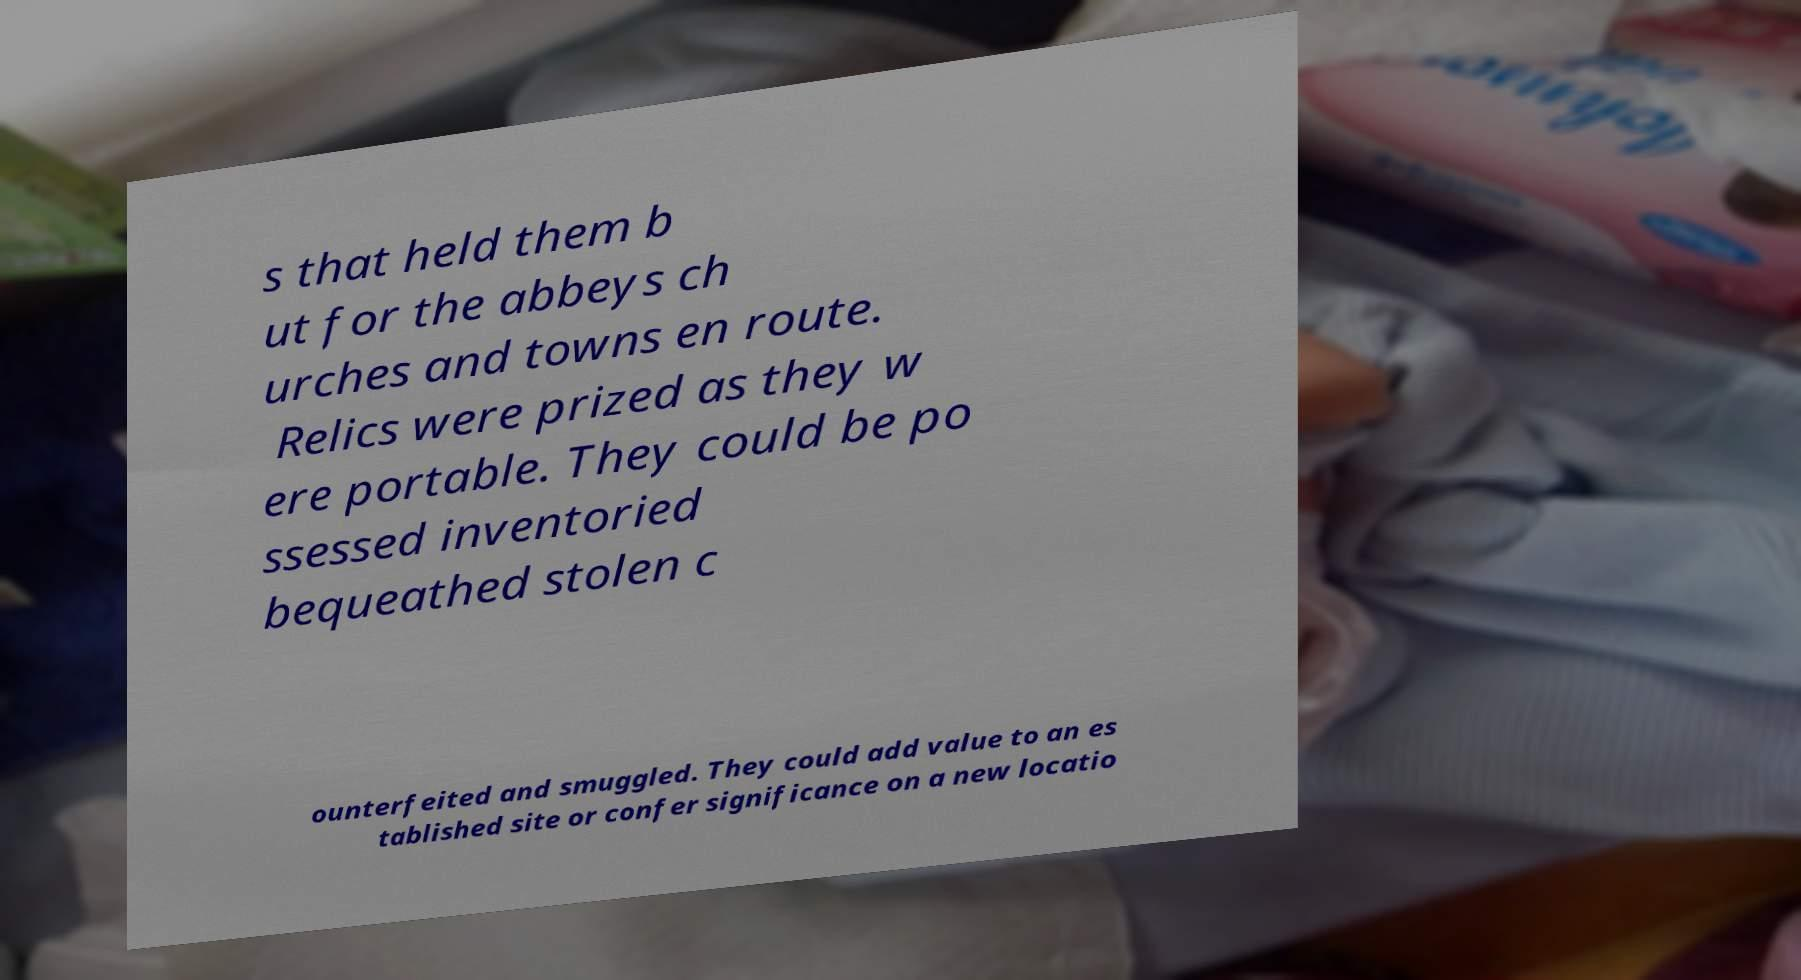Can you accurately transcribe the text from the provided image for me? s that held them b ut for the abbeys ch urches and towns en route. Relics were prized as they w ere portable. They could be po ssessed inventoried bequeathed stolen c ounterfeited and smuggled. They could add value to an es tablished site or confer significance on a new locatio 